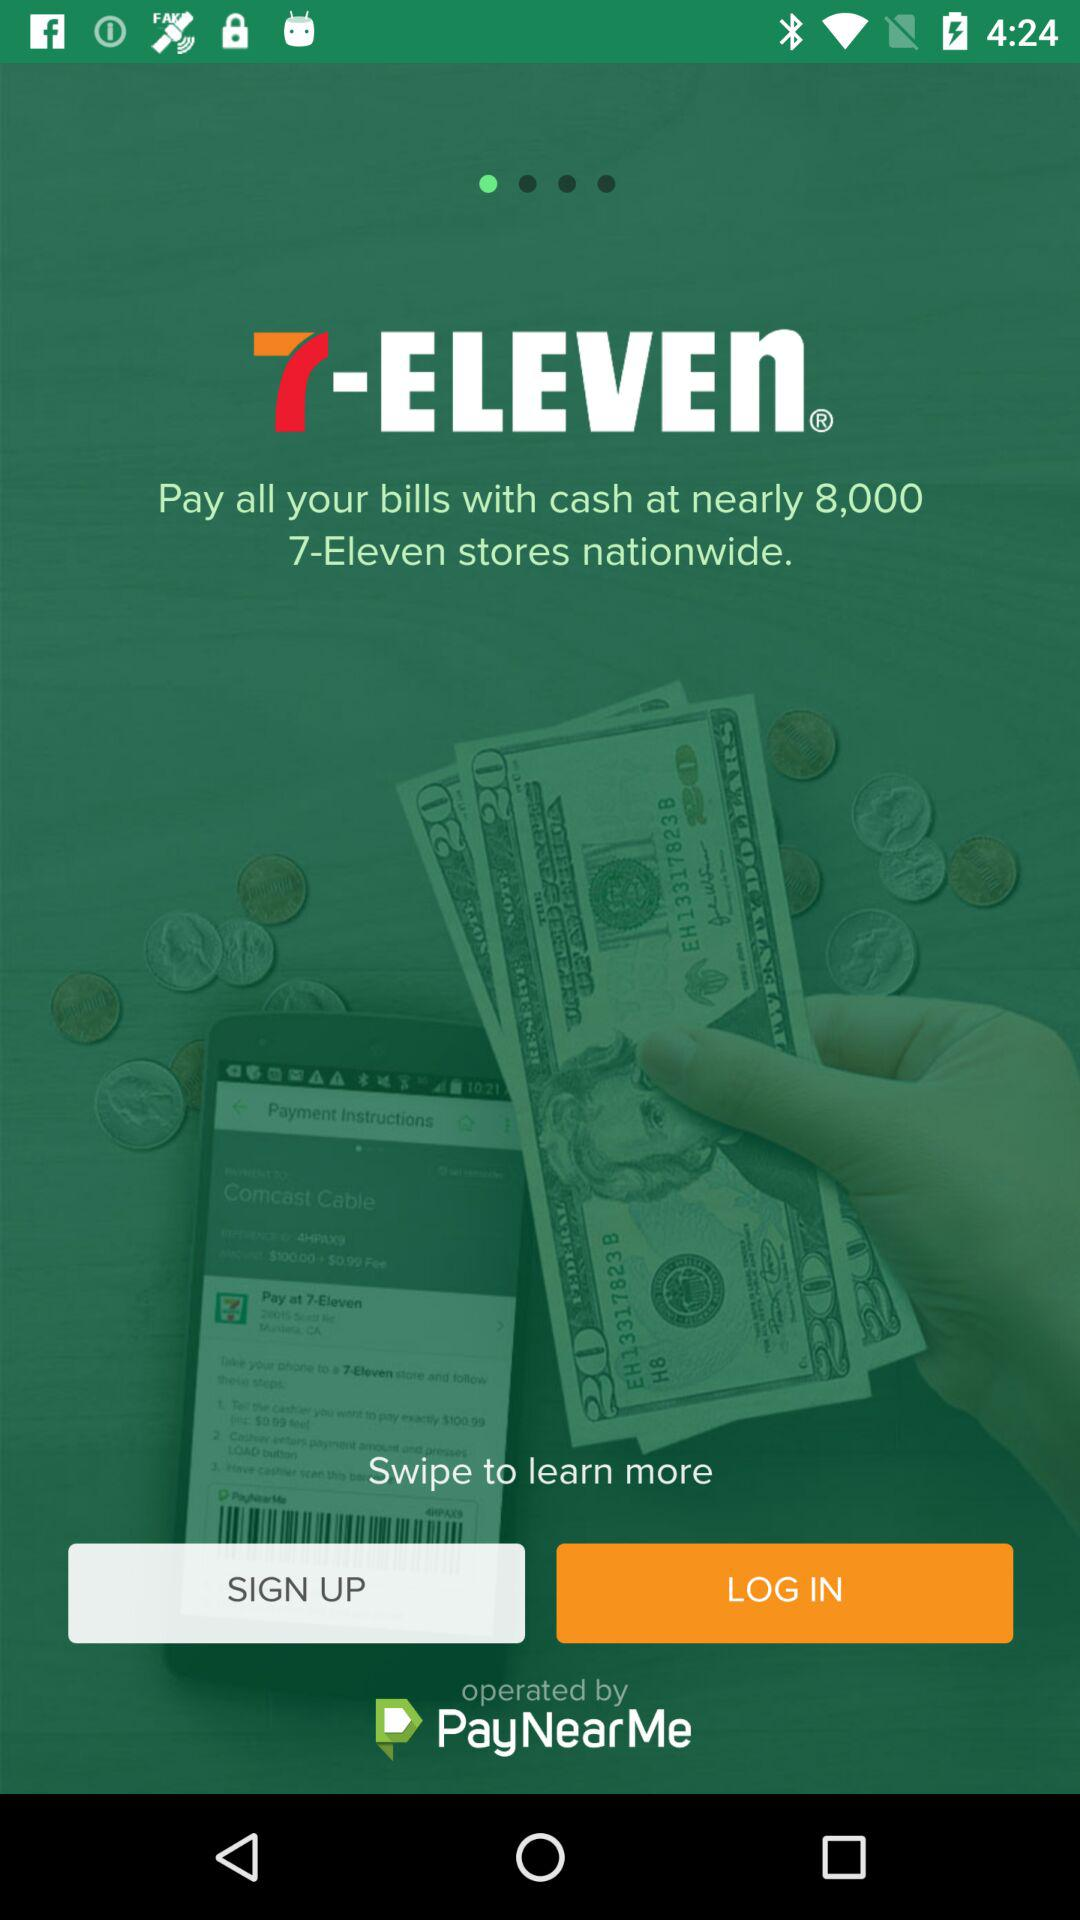What is the application name? The application name is "7-ELEVEN". 